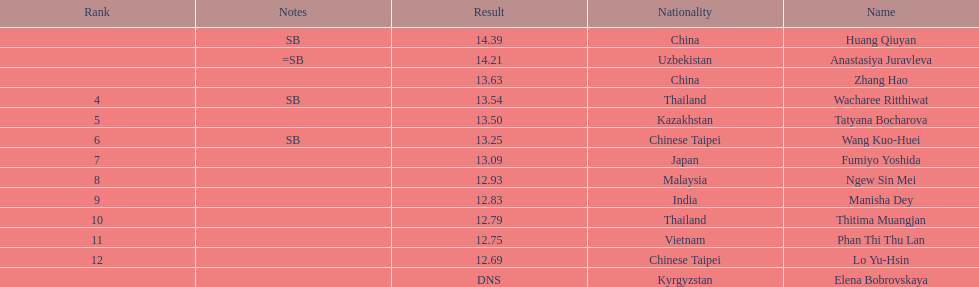Which country came in first? China. 